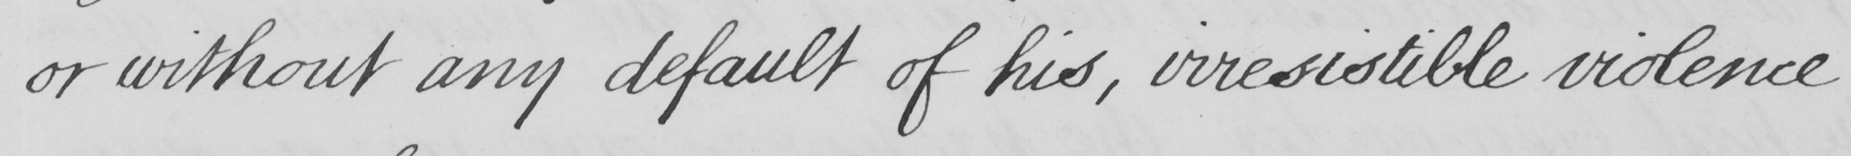What does this handwritten line say? or without any default of his , irresistible violence 